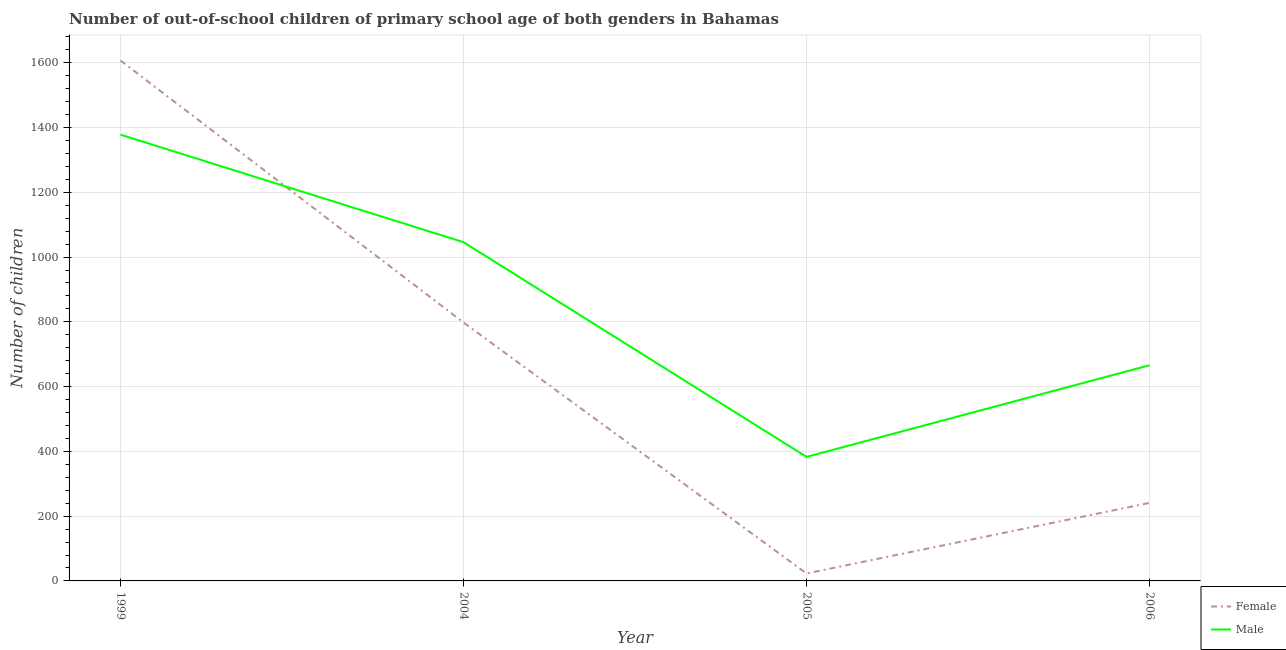What is the number of male out-of-school students in 2004?
Offer a very short reply. 1046. Across all years, what is the maximum number of female out-of-school students?
Offer a very short reply. 1607. Across all years, what is the minimum number of female out-of-school students?
Ensure brevity in your answer.  23. In which year was the number of female out-of-school students minimum?
Your answer should be very brief. 2005. What is the total number of male out-of-school students in the graph?
Keep it short and to the point. 3473. What is the difference between the number of female out-of-school students in 2005 and that in 2006?
Make the answer very short. -218. What is the difference between the number of female out-of-school students in 2004 and the number of male out-of-school students in 1999?
Your answer should be compact. -580. What is the average number of male out-of-school students per year?
Your answer should be very brief. 868.25. In the year 1999, what is the difference between the number of female out-of-school students and number of male out-of-school students?
Offer a very short reply. 229. What is the ratio of the number of male out-of-school students in 1999 to that in 2006?
Keep it short and to the point. 2.07. Is the number of female out-of-school students in 1999 less than that in 2004?
Make the answer very short. No. Is the difference between the number of female out-of-school students in 2004 and 2006 greater than the difference between the number of male out-of-school students in 2004 and 2006?
Your answer should be very brief. Yes. What is the difference between the highest and the second highest number of female out-of-school students?
Your answer should be very brief. 809. What is the difference between the highest and the lowest number of female out-of-school students?
Keep it short and to the point. 1584. Is the sum of the number of male out-of-school students in 1999 and 2004 greater than the maximum number of female out-of-school students across all years?
Provide a succinct answer. Yes. Is the number of female out-of-school students strictly greater than the number of male out-of-school students over the years?
Make the answer very short. No. Is the number of male out-of-school students strictly less than the number of female out-of-school students over the years?
Ensure brevity in your answer.  No. How many lines are there?
Make the answer very short. 2. How many years are there in the graph?
Provide a succinct answer. 4. What is the difference between two consecutive major ticks on the Y-axis?
Keep it short and to the point. 200. Are the values on the major ticks of Y-axis written in scientific E-notation?
Keep it short and to the point. No. Does the graph contain any zero values?
Your answer should be very brief. No. Where does the legend appear in the graph?
Your answer should be compact. Bottom right. How many legend labels are there?
Your answer should be very brief. 2. What is the title of the graph?
Make the answer very short. Number of out-of-school children of primary school age of both genders in Bahamas. Does "Ages 15-24" appear as one of the legend labels in the graph?
Keep it short and to the point. No. What is the label or title of the Y-axis?
Offer a terse response. Number of children. What is the Number of children in Female in 1999?
Your response must be concise. 1607. What is the Number of children of Male in 1999?
Offer a terse response. 1378. What is the Number of children of Female in 2004?
Keep it short and to the point. 798. What is the Number of children in Male in 2004?
Your answer should be compact. 1046. What is the Number of children in Male in 2005?
Your response must be concise. 383. What is the Number of children in Female in 2006?
Provide a short and direct response. 241. What is the Number of children of Male in 2006?
Provide a succinct answer. 666. Across all years, what is the maximum Number of children of Female?
Keep it short and to the point. 1607. Across all years, what is the maximum Number of children in Male?
Offer a very short reply. 1378. Across all years, what is the minimum Number of children in Female?
Provide a succinct answer. 23. Across all years, what is the minimum Number of children in Male?
Your answer should be compact. 383. What is the total Number of children in Female in the graph?
Give a very brief answer. 2669. What is the total Number of children of Male in the graph?
Offer a terse response. 3473. What is the difference between the Number of children in Female in 1999 and that in 2004?
Your answer should be very brief. 809. What is the difference between the Number of children in Male in 1999 and that in 2004?
Keep it short and to the point. 332. What is the difference between the Number of children of Female in 1999 and that in 2005?
Your answer should be very brief. 1584. What is the difference between the Number of children in Male in 1999 and that in 2005?
Your answer should be very brief. 995. What is the difference between the Number of children of Female in 1999 and that in 2006?
Make the answer very short. 1366. What is the difference between the Number of children in Male in 1999 and that in 2006?
Your answer should be compact. 712. What is the difference between the Number of children of Female in 2004 and that in 2005?
Give a very brief answer. 775. What is the difference between the Number of children in Male in 2004 and that in 2005?
Your response must be concise. 663. What is the difference between the Number of children of Female in 2004 and that in 2006?
Offer a very short reply. 557. What is the difference between the Number of children of Male in 2004 and that in 2006?
Your response must be concise. 380. What is the difference between the Number of children of Female in 2005 and that in 2006?
Ensure brevity in your answer.  -218. What is the difference between the Number of children of Male in 2005 and that in 2006?
Make the answer very short. -283. What is the difference between the Number of children of Female in 1999 and the Number of children of Male in 2004?
Keep it short and to the point. 561. What is the difference between the Number of children of Female in 1999 and the Number of children of Male in 2005?
Ensure brevity in your answer.  1224. What is the difference between the Number of children in Female in 1999 and the Number of children in Male in 2006?
Provide a short and direct response. 941. What is the difference between the Number of children of Female in 2004 and the Number of children of Male in 2005?
Your answer should be compact. 415. What is the difference between the Number of children of Female in 2004 and the Number of children of Male in 2006?
Provide a short and direct response. 132. What is the difference between the Number of children in Female in 2005 and the Number of children in Male in 2006?
Offer a terse response. -643. What is the average Number of children in Female per year?
Provide a short and direct response. 667.25. What is the average Number of children of Male per year?
Provide a short and direct response. 868.25. In the year 1999, what is the difference between the Number of children of Female and Number of children of Male?
Your answer should be compact. 229. In the year 2004, what is the difference between the Number of children of Female and Number of children of Male?
Your response must be concise. -248. In the year 2005, what is the difference between the Number of children of Female and Number of children of Male?
Give a very brief answer. -360. In the year 2006, what is the difference between the Number of children in Female and Number of children in Male?
Give a very brief answer. -425. What is the ratio of the Number of children of Female in 1999 to that in 2004?
Provide a short and direct response. 2.01. What is the ratio of the Number of children in Male in 1999 to that in 2004?
Give a very brief answer. 1.32. What is the ratio of the Number of children of Female in 1999 to that in 2005?
Ensure brevity in your answer.  69.87. What is the ratio of the Number of children of Male in 1999 to that in 2005?
Ensure brevity in your answer.  3.6. What is the ratio of the Number of children in Female in 1999 to that in 2006?
Keep it short and to the point. 6.67. What is the ratio of the Number of children of Male in 1999 to that in 2006?
Make the answer very short. 2.07. What is the ratio of the Number of children in Female in 2004 to that in 2005?
Provide a succinct answer. 34.7. What is the ratio of the Number of children of Male in 2004 to that in 2005?
Make the answer very short. 2.73. What is the ratio of the Number of children in Female in 2004 to that in 2006?
Make the answer very short. 3.31. What is the ratio of the Number of children of Male in 2004 to that in 2006?
Give a very brief answer. 1.57. What is the ratio of the Number of children in Female in 2005 to that in 2006?
Your answer should be compact. 0.1. What is the ratio of the Number of children in Male in 2005 to that in 2006?
Provide a succinct answer. 0.58. What is the difference between the highest and the second highest Number of children in Female?
Give a very brief answer. 809. What is the difference between the highest and the second highest Number of children in Male?
Your answer should be very brief. 332. What is the difference between the highest and the lowest Number of children in Female?
Keep it short and to the point. 1584. What is the difference between the highest and the lowest Number of children in Male?
Offer a very short reply. 995. 